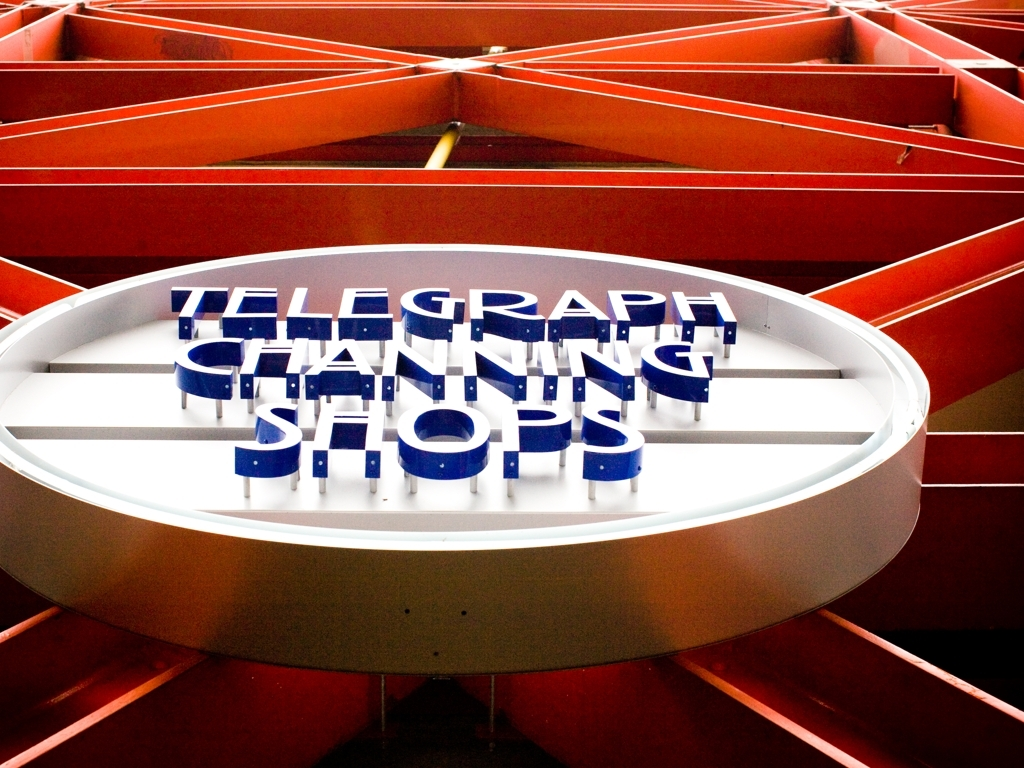What design elements make the signage in the picture stand out? The signage in the image uses bold, contrasting colors with a vivid blue against an orange backdrop, effectively catching the eye. The three-dimensional letters add depth and presence, and the circular design creates a focal point that draws viewer attention. 